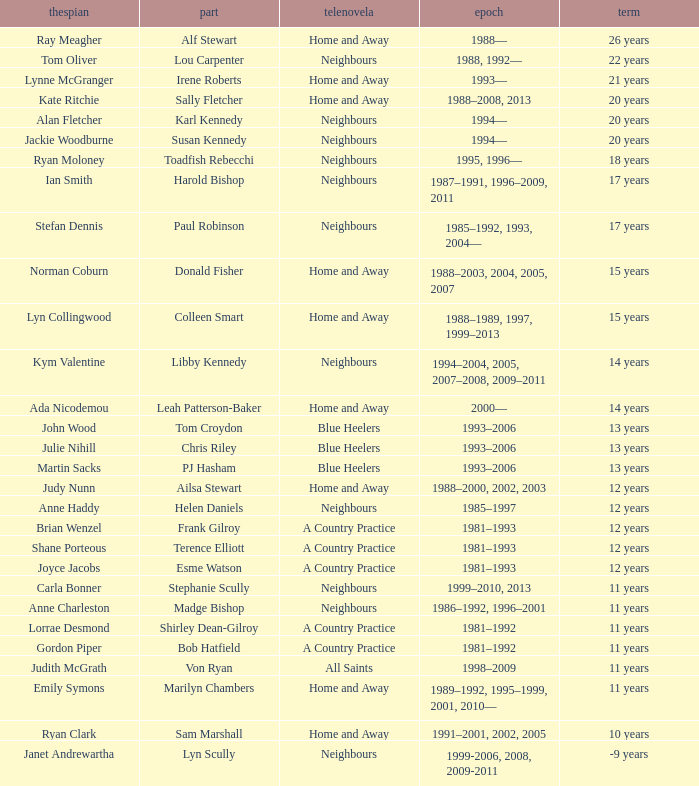Which actor played on Home and Away for 20 years? Kate Ritchie. 